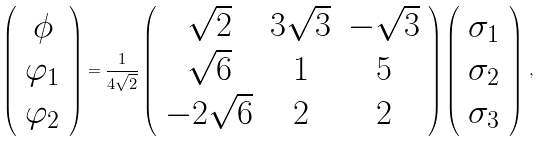Convert formula to latex. <formula><loc_0><loc_0><loc_500><loc_500>\left ( \begin{array} { c } \phi \\ \varphi _ { 1 } \\ \varphi _ { 2 } \end{array} \right ) = \frac { 1 } { 4 \sqrt { 2 } } \left ( \begin{array} { c c c } \sqrt { 2 } & 3 \sqrt { 3 } & - \sqrt { 3 } \\ \sqrt { 6 } & 1 & 5 \\ - 2 \sqrt { 6 } & 2 & 2 \end{array} \right ) \left ( \begin{array} { c } \sigma _ { 1 } \\ \sigma _ { 2 } \\ \sigma _ { 3 } \end{array} \right ) \, ,</formula> 